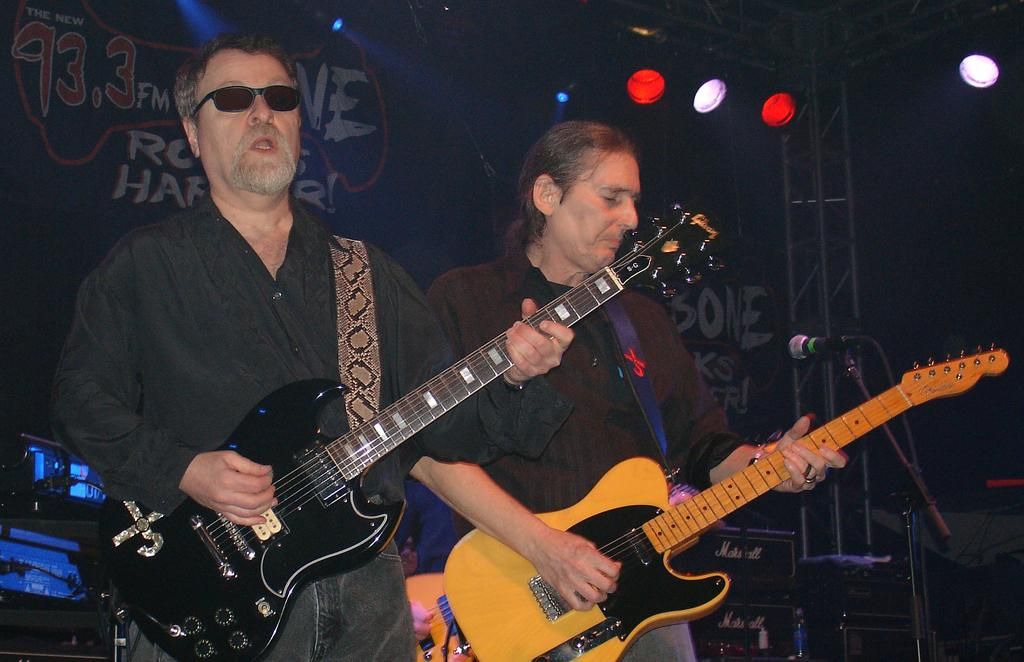How many people are in the image? There are two people in the image. What are the people doing in the image? The people are standing and playing guitars. What equipment is present in the image? There is a microphone with a stand in the image. Can you describe the background of the image? The background of the image is dark, and there are devices, rods, a banner, and focusing lights visible. What type of alley can be seen behind the people in the image? There is no alley visible in the image; the background consists of a dark setting with various objects. What direction is the zephyr blowing in the image? There is no mention of a zephyr or any wind in the image; it is focused on the people playing guitars and the equipment present. 